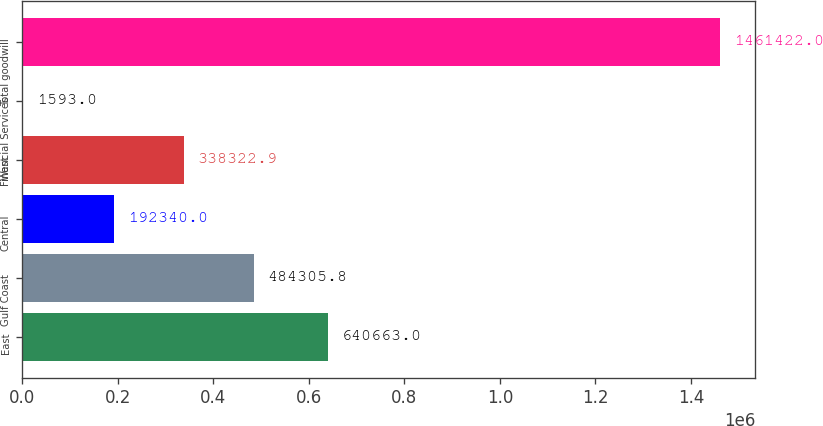Convert chart. <chart><loc_0><loc_0><loc_500><loc_500><bar_chart><fcel>East<fcel>Gulf Coast<fcel>Central<fcel>West<fcel>Financial Services<fcel>Total goodwill<nl><fcel>640663<fcel>484306<fcel>192340<fcel>338323<fcel>1593<fcel>1.46142e+06<nl></chart> 